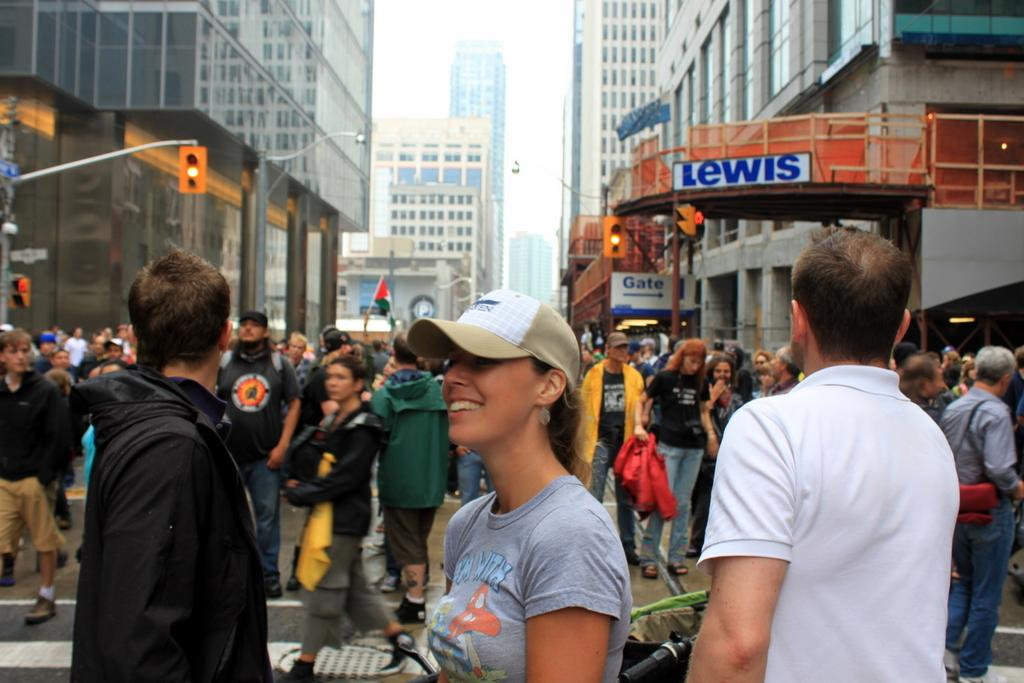What can be seen on the surface in the image? There are people standing on the surface in the image. What structures are present in the image? There are traffic light poles and buildings visible in the image. How many oranges are hanging from the traffic light poles in the image? There are no oranges present on the traffic light poles in the image. What type of ray is visible in the image? There is no ray visible in the image. 